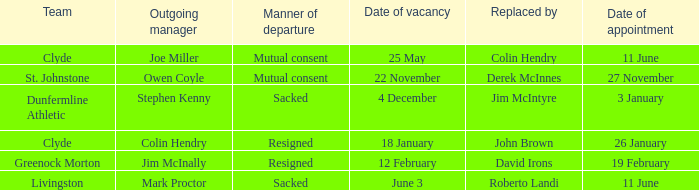Which manager is stepping down on the date of november 22nd? Owen Coyle. 